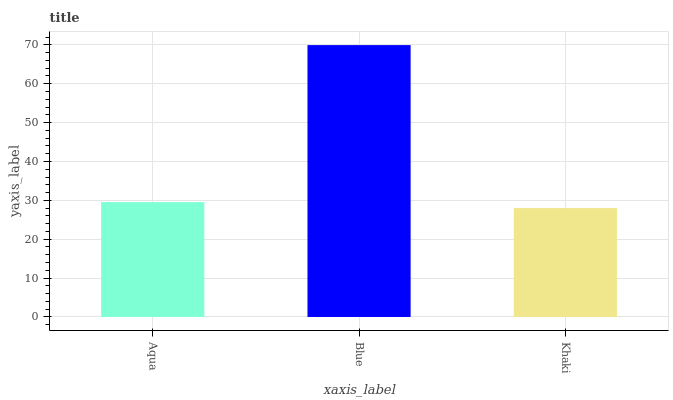Is Blue the minimum?
Answer yes or no. No. Is Khaki the maximum?
Answer yes or no. No. Is Blue greater than Khaki?
Answer yes or no. Yes. Is Khaki less than Blue?
Answer yes or no. Yes. Is Khaki greater than Blue?
Answer yes or no. No. Is Blue less than Khaki?
Answer yes or no. No. Is Aqua the high median?
Answer yes or no. Yes. Is Aqua the low median?
Answer yes or no. Yes. Is Khaki the high median?
Answer yes or no. No. Is Khaki the low median?
Answer yes or no. No. 